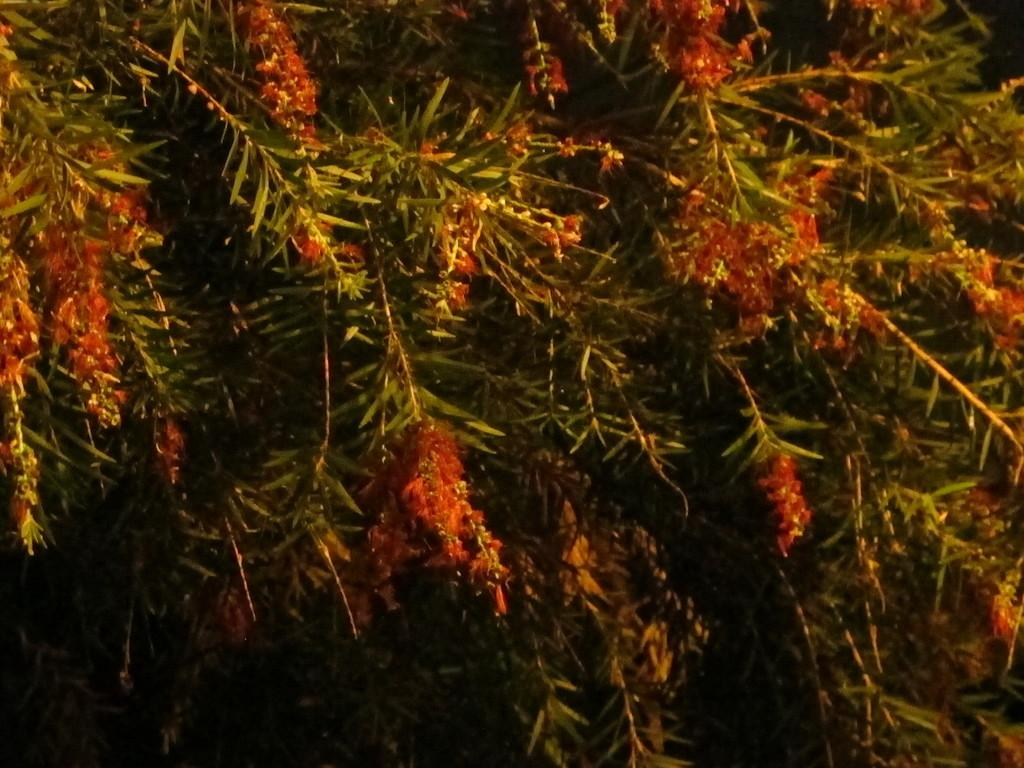What is present in the image? There is a tree in the image. What feature of the tree is mentioned? The tree has flowers. What can be said about the color of the flowers? The flowers are red in color. Can you describe the feather texture in the image? There is no feather present in the image; it features a tree with red flowers. 